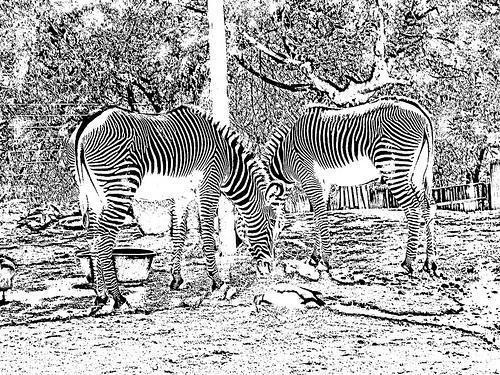How many animals are visible?
Give a very brief answer. 2. 